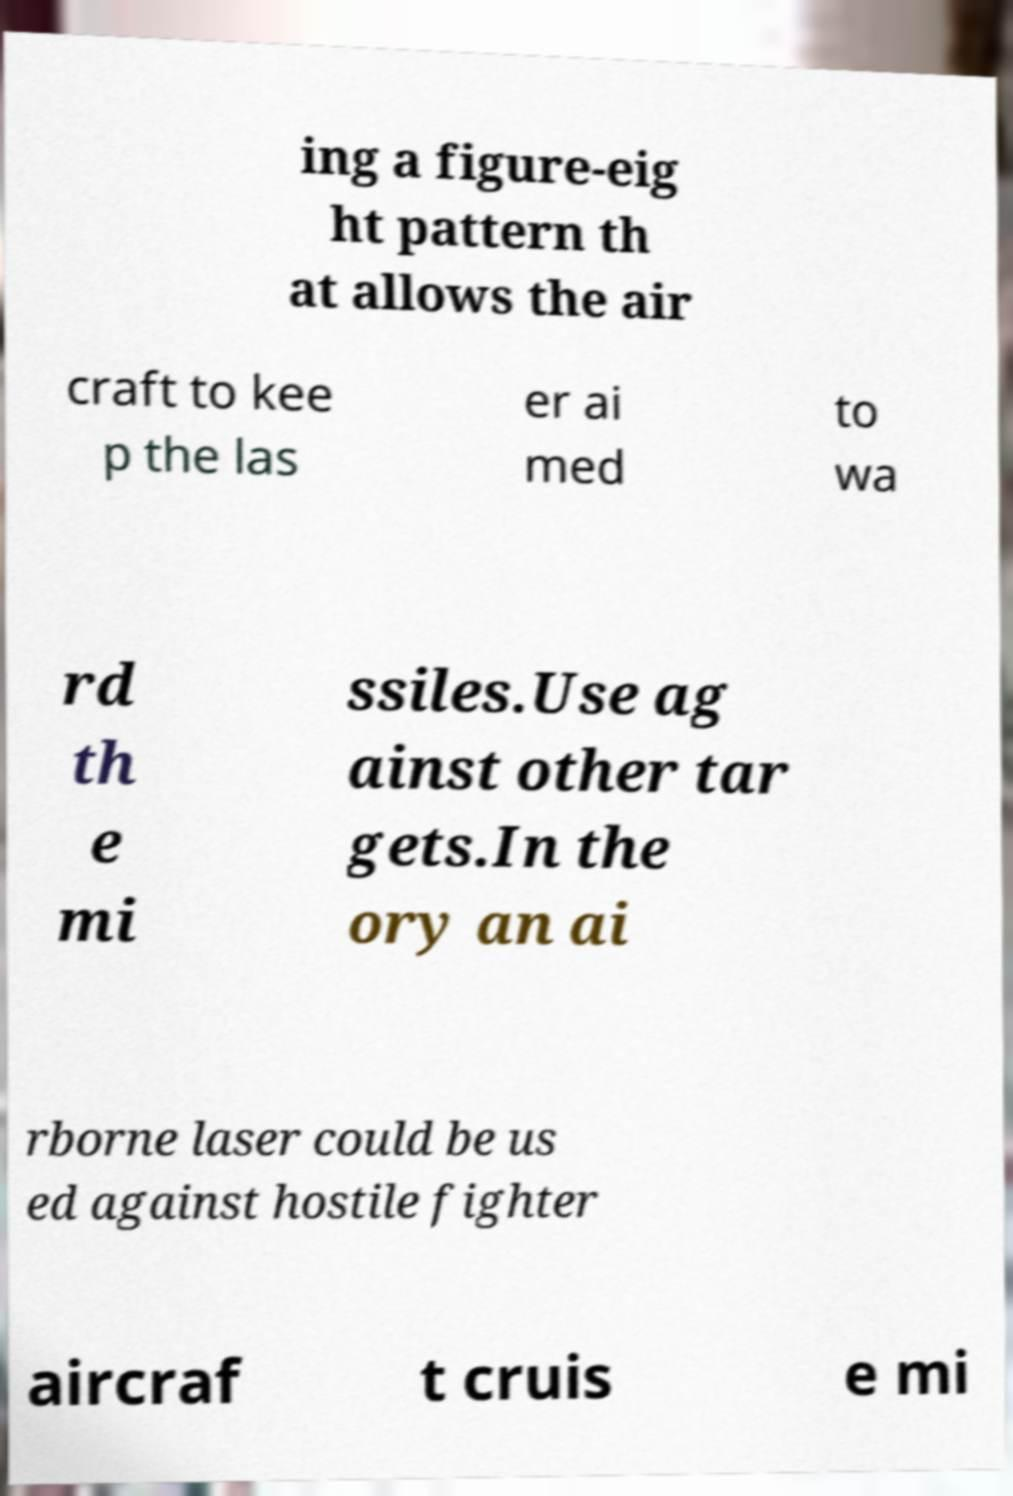There's text embedded in this image that I need extracted. Can you transcribe it verbatim? ing a figure-eig ht pattern th at allows the air craft to kee p the las er ai med to wa rd th e mi ssiles.Use ag ainst other tar gets.In the ory an ai rborne laser could be us ed against hostile fighter aircraf t cruis e mi 